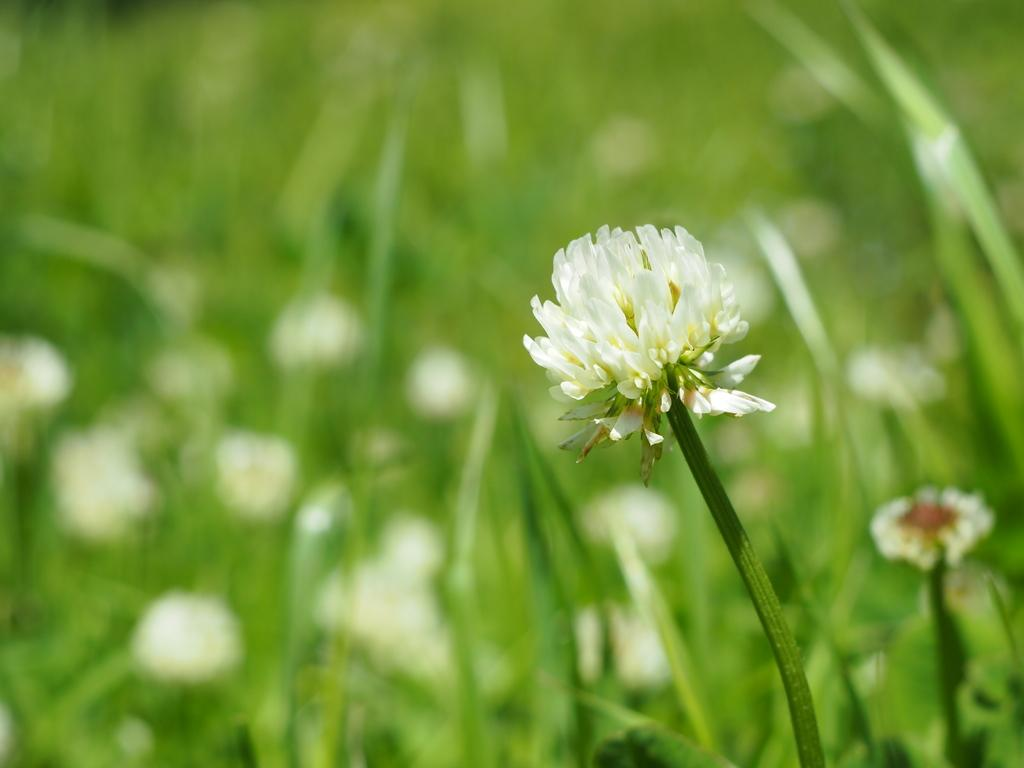What is the main subject of the image? There is a flower in the image. How would you describe the background of the image? The background of the image is blurred. What type of vegetation can be seen in the background? There is greenery visible in the background. Can you tell me how many goldfish are swimming in the image? There are no goldfish present in the image; it features a flower and a blurred background. Is there any indication of approval or disapproval in the image? There is no indication of approval or disapproval in the image, as it only contains a flower and a blurred background. 